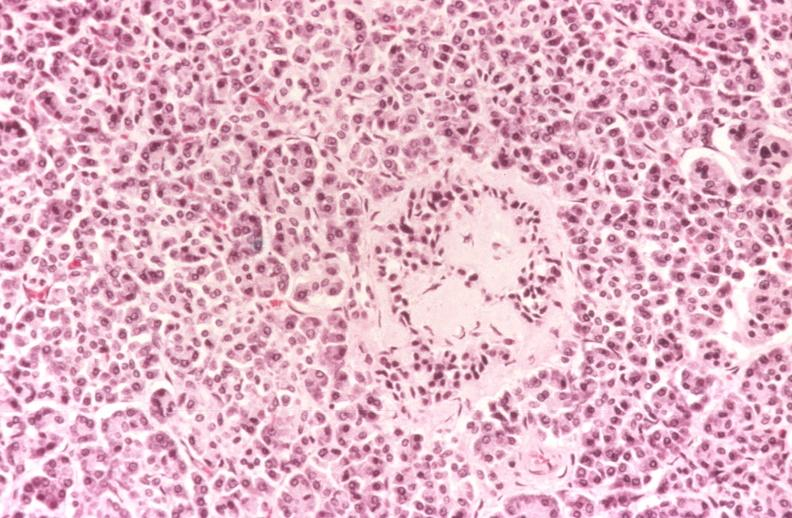what is present?
Answer the question using a single word or phrase. Pancreas 